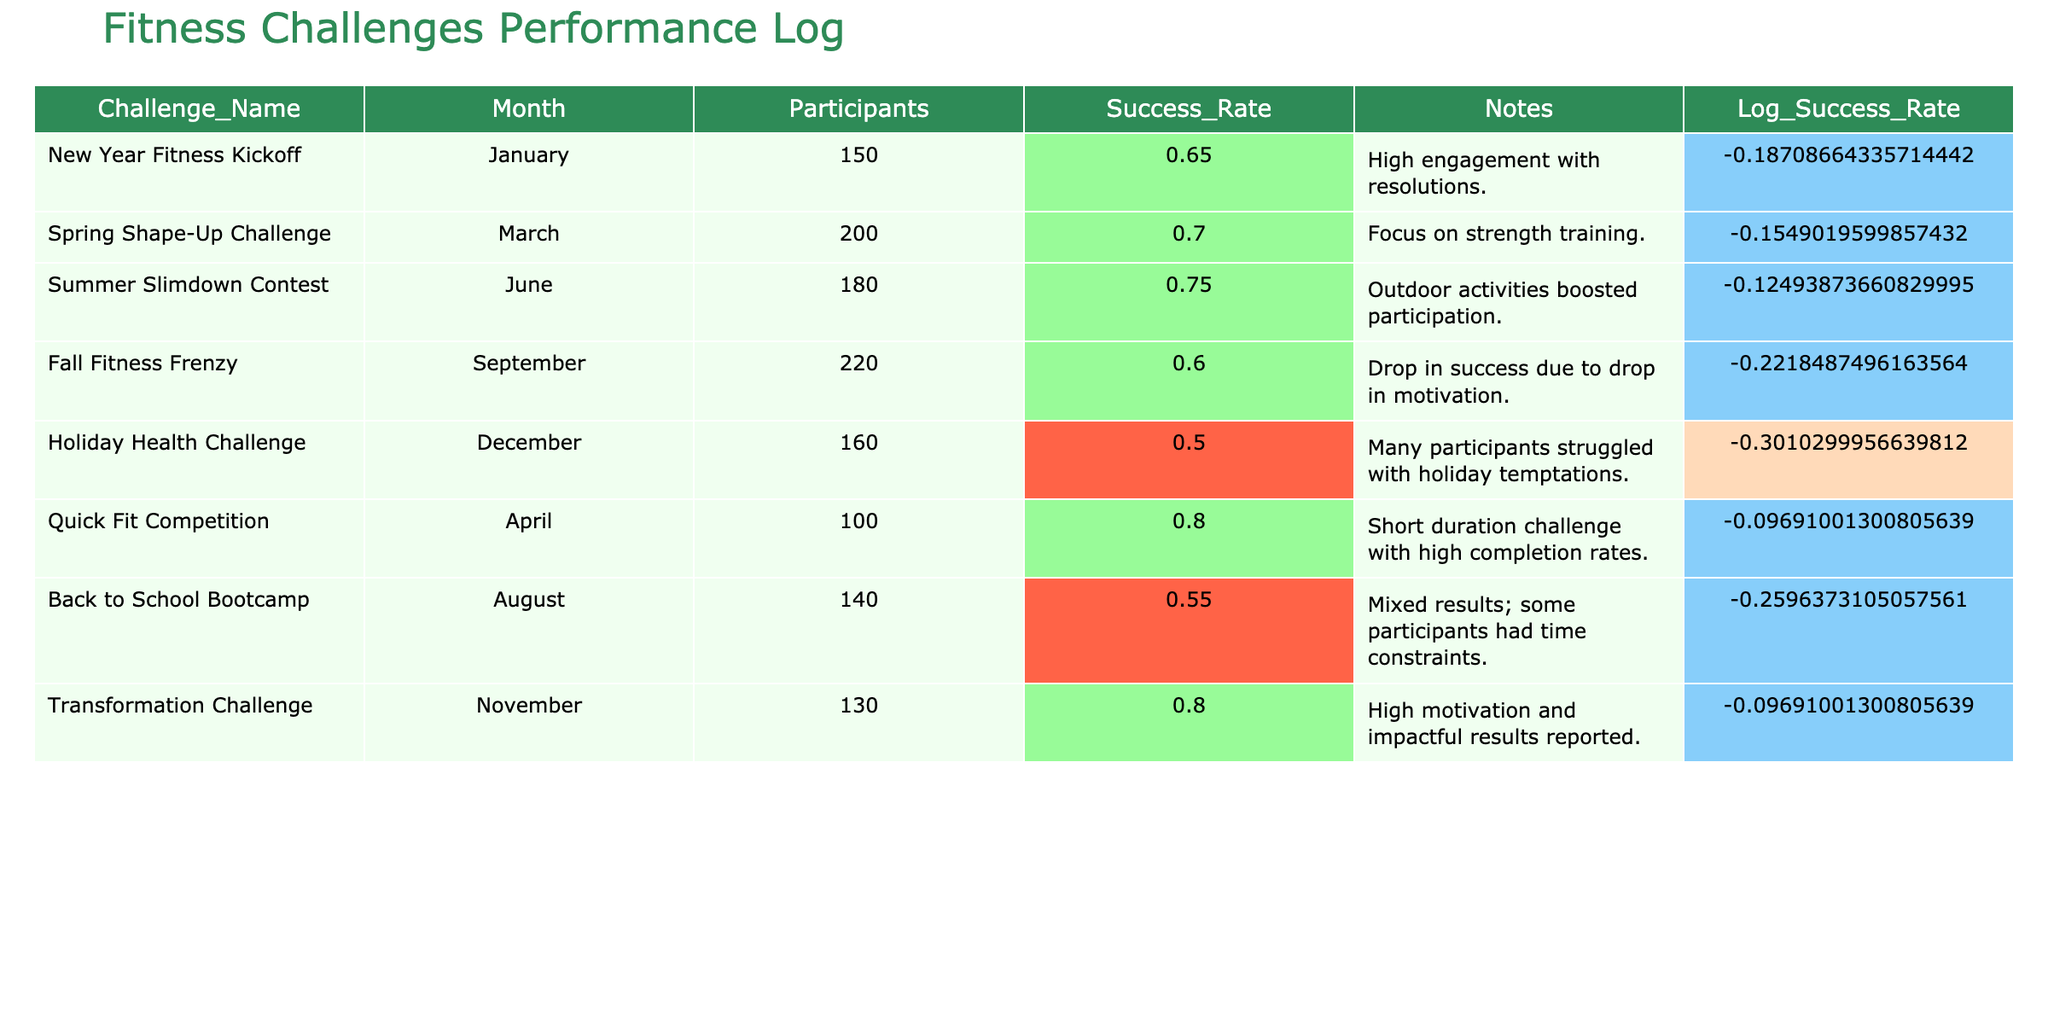What was the success rate for the Quick Fit Competition? The Quick Fit Competition has a listed success rate of 0.80 in the table.
Answer: 0.80 Which challenge had the highest number of participants? The Fall Fitness Frenzy had the highest number of participants at 220, compared to other challenges listed.
Answer: 220 What is the average success rate of the challenges taking place in the first half of the year (January to June)? The success rates for the challenges in the first half are 0.65 (January), 0.70 (March), 0.80 (April), and 0.75 (June). Adding these gives 0.65 + 0.70 + 0.80 + 0.75 = 2.90. There are 4 challenges, so the average is 2.90 / 4 = 0.725.
Answer: 0.725 Did any challenge experience a drop in success rate below 0.6? Yes, both the Fall Fitness Frenzy (0.60) and the Holiday Health Challenge (0.50) had success rates below 0.6.
Answer: Yes Which month had the lowest success rate and what was it? The month with the lowest success rate is December during the Holiday Health Challenge, with a rate of 0.50, making it the lowest compared to other challenges.
Answer: 0.50 How many challenges had a success rate of 0.70 or higher? The challenges with a success rate of 0.70 or higher are the Spring Shape-Up Challenge (0.70), Quick Fit Competition (0.80), Summer Slimdown Contest (0.75), and Transformation Challenge (0.80). That totals to 4 challenges.
Answer: 4 What is the difference in success rates between the New Year Fitness Kickoff and the Holiday Health Challenge? The success rate for the New Year Fitness Kickoff is 0.65, while for the Holiday Health Challenge it is 0.50. The difference is 0.65 - 0.50 = 0.15.
Answer: 0.15 Which challenge had a success rate higher than 0.6 but lower than 0.75? The Spring Shape-Up Challenge with a success rate of 0.70 fits this category as it is greater than 0.60 but less than 0.75.
Answer: Spring Shape-Up Challenge 